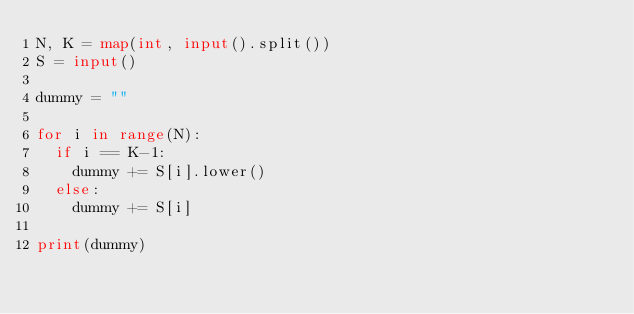Convert code to text. <code><loc_0><loc_0><loc_500><loc_500><_Python_>N, K = map(int, input().split())
S = input()
 
dummy = ""
 
for i in range(N):
  if i == K-1:
    dummy += S[i].lower()
  else:
    dummy += S[i]
    
print(dummy)</code> 